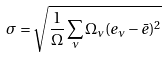<formula> <loc_0><loc_0><loc_500><loc_500>\sigma = \sqrt { \frac { 1 } { \Omega } \sum _ { \nu } \Omega _ { \nu } ( e _ { \nu } - \bar { e } ) ^ { 2 } }</formula> 